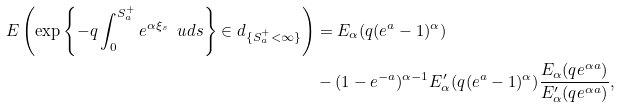<formula> <loc_0><loc_0><loc_500><loc_500>E \left ( \exp \left \{ - q \int _ { 0 } ^ { S ^ { + } _ { a } } e ^ { \alpha \xi _ { s } } \ u d s \right \} \in d _ { \{ S ^ { + } _ { a } < \infty \} } \right ) & = E _ { \alpha } ( q ( e ^ { a } - 1 ) ^ { \alpha } ) \\ & - ( 1 - e ^ { - a } ) ^ { \alpha - 1 } E ^ { \prime } _ { \alpha } ( q ( e ^ { a } - 1 ) ^ { \alpha } ) \frac { E _ { \alpha } ( q e ^ { \alpha a } ) } { E ^ { \prime } _ { \alpha } ( q e ^ { \alpha a } ) } ,</formula> 